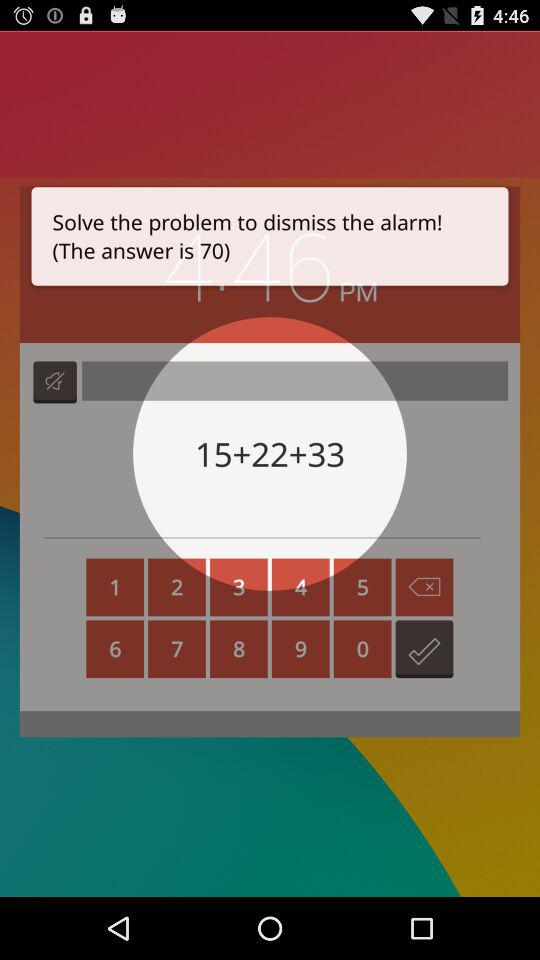What should I do to dismiss the alarm? You should solve the problem to dismiss the alarm. 